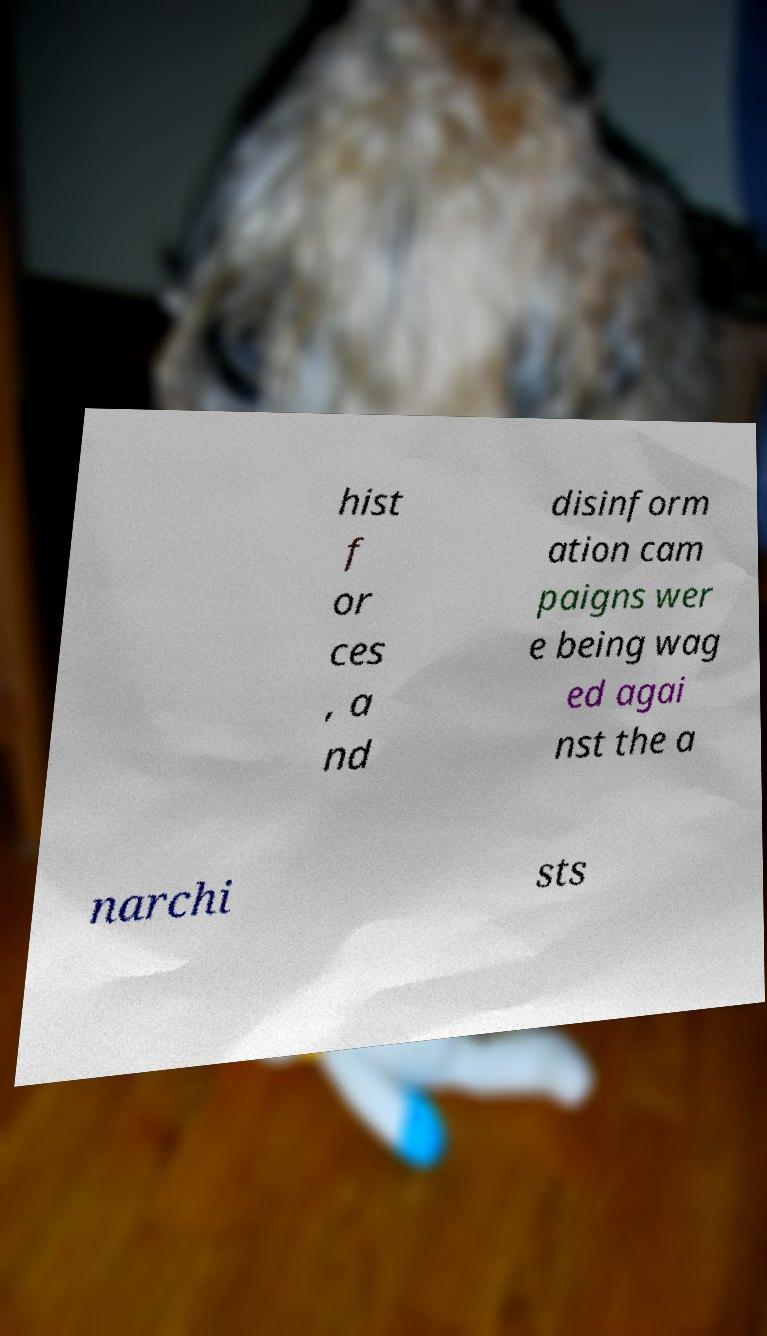I need the written content from this picture converted into text. Can you do that? hist f or ces , a nd disinform ation cam paigns wer e being wag ed agai nst the a narchi sts 